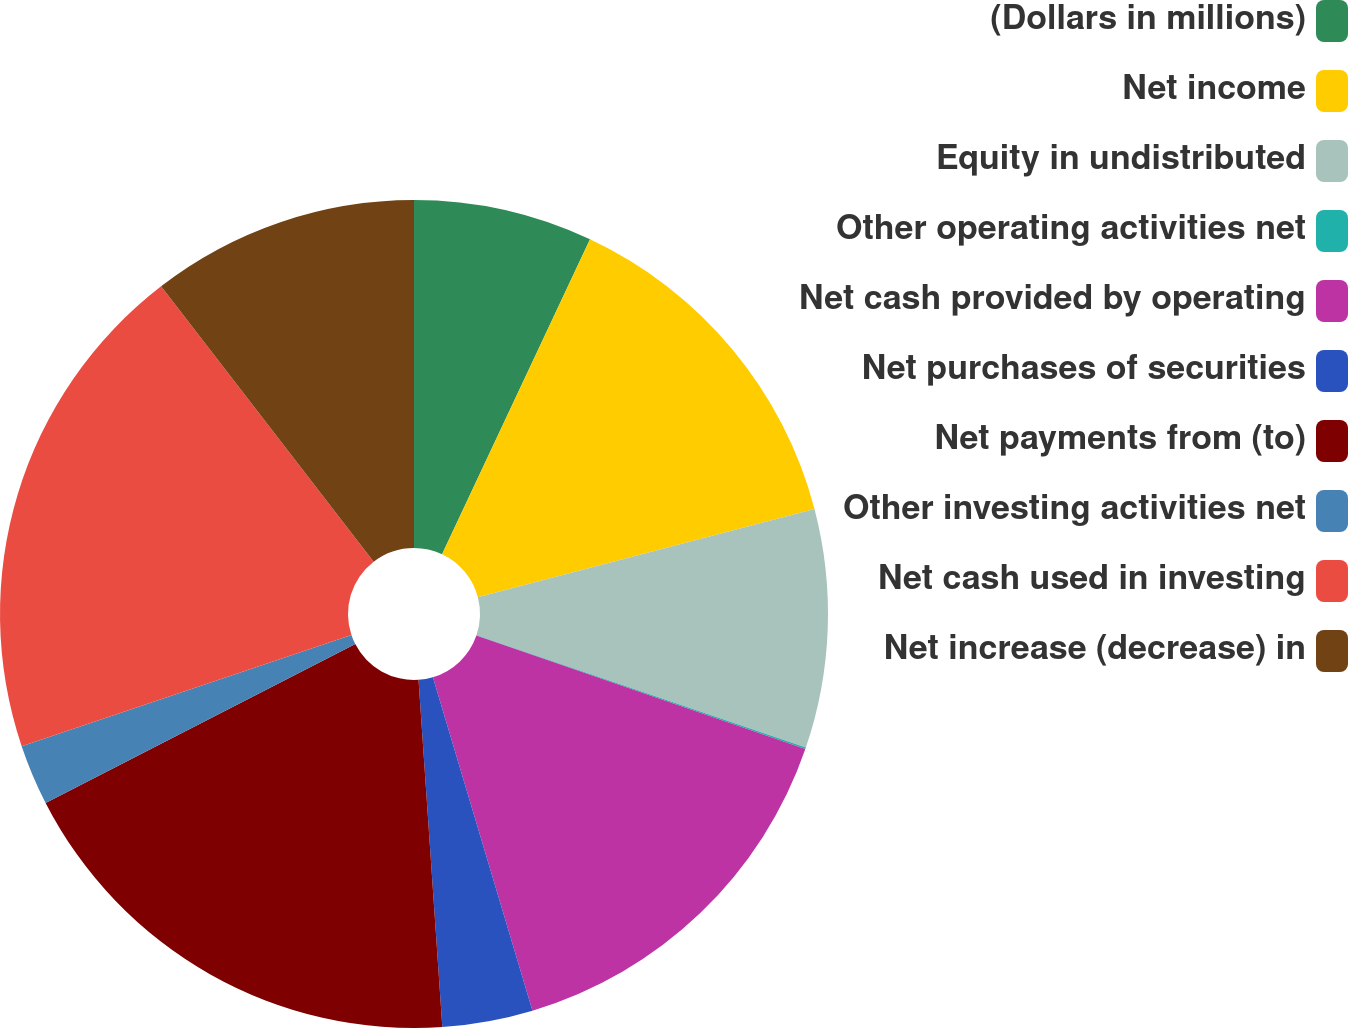<chart> <loc_0><loc_0><loc_500><loc_500><pie_chart><fcel>(Dollars in millions)<fcel>Net income<fcel>Equity in undistributed<fcel>Other operating activities net<fcel>Net cash provided by operating<fcel>Net purchases of securities<fcel>Net payments from (to)<fcel>Other investing activities net<fcel>Net cash used in investing<fcel>Net increase (decrease) in<nl><fcel>6.99%<fcel>13.93%<fcel>9.31%<fcel>0.06%<fcel>15.09%<fcel>3.53%<fcel>18.55%<fcel>2.37%<fcel>19.71%<fcel>10.46%<nl></chart> 